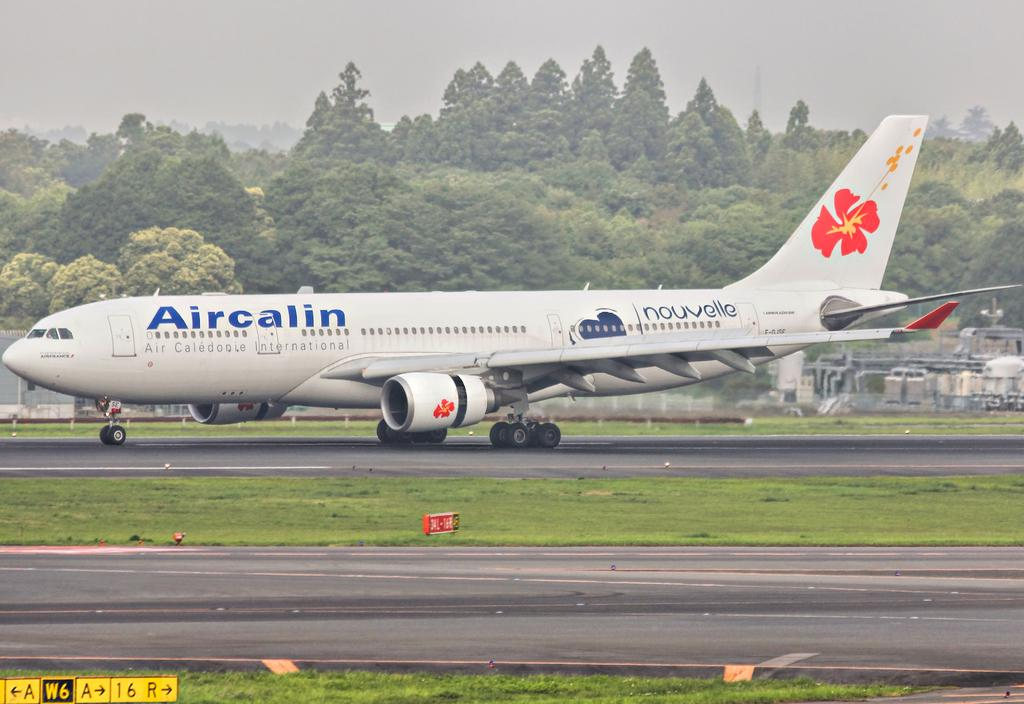<image>
Render a clear and concise summary of the photo. An Aircalin passenger plane lands on the runway. 